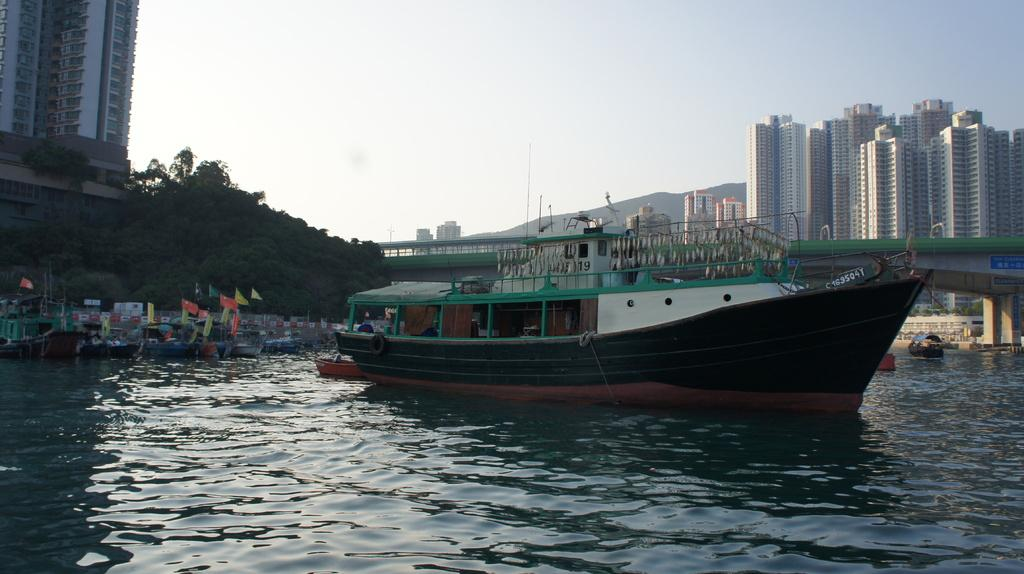<image>
Write a terse but informative summary of the picture. A medium sized boat with C 163504Y on the front of it. 